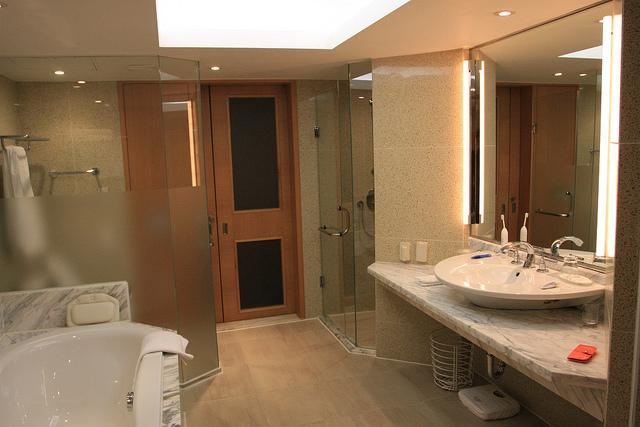What color is the little purse on the marble countertop next to the big raised sink?

Choices:
A) green
B) blue
C) orange
D) pink orange 